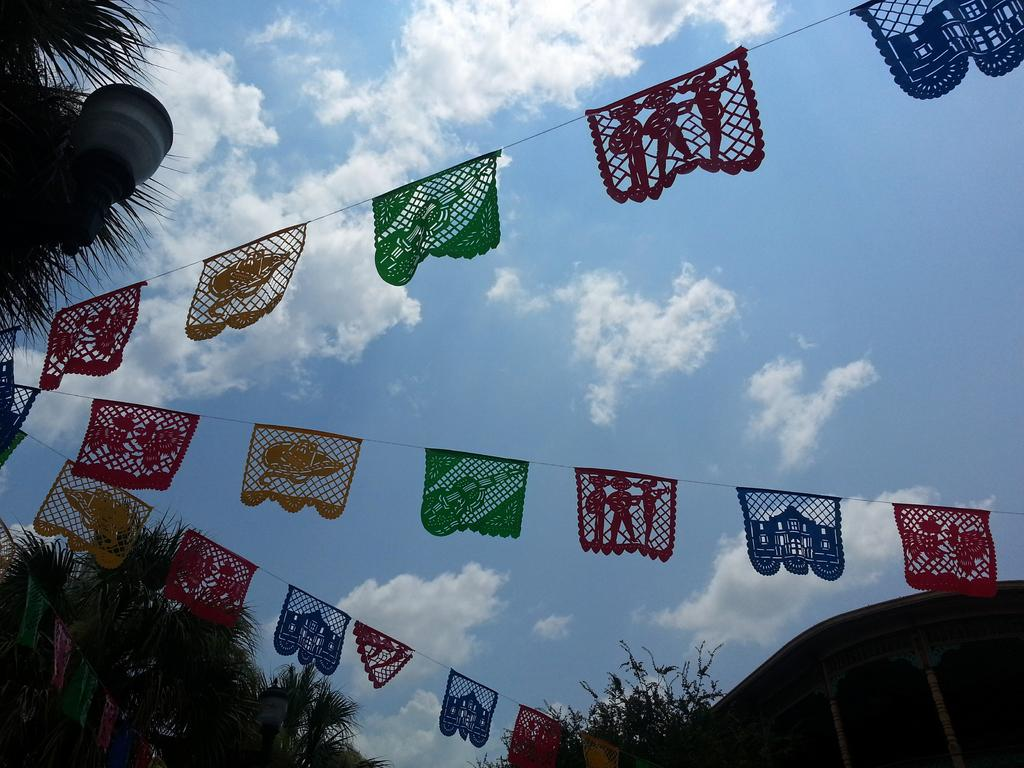What type of natural vegetation can be seen in the image? There are trees in the image. What is the source of light visible in the image? There is light visible in the image. What type of man-made structure is present in the image? There is a building in the image. What type of symbolic objects are present in the image? There are flags in the image. What type of atmospheric phenomena can be seen in the image? There are clouds visible in the image. What type of polish is being used on the toothpaste in the image? There is no toothpaste or polish present in the image. Where is the pocket located in the image? There is no pocket present in the image. 